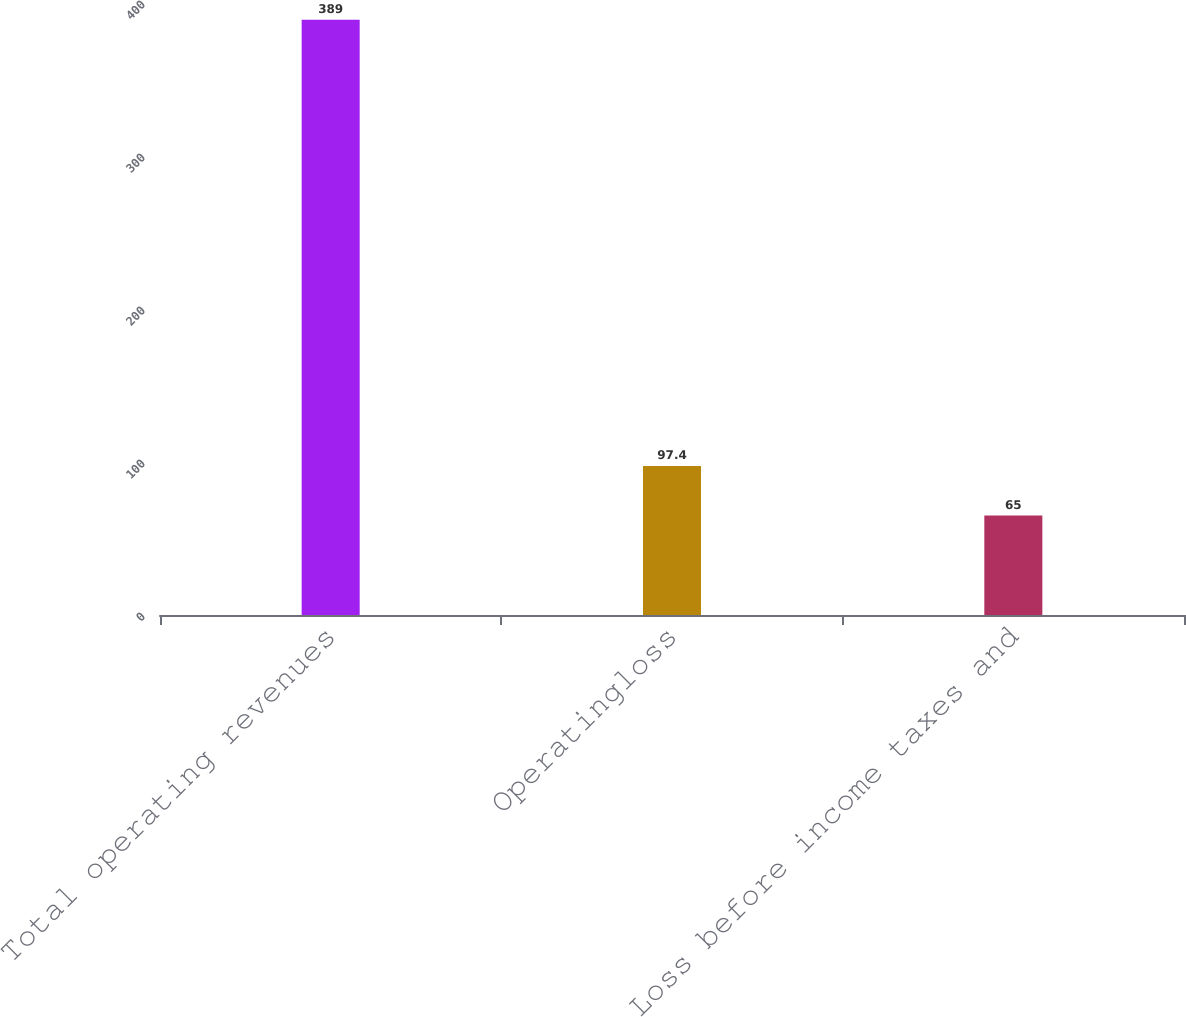<chart> <loc_0><loc_0><loc_500><loc_500><bar_chart><fcel>Total operating revenues<fcel>Operatingloss<fcel>Loss before income taxes and<nl><fcel>389<fcel>97.4<fcel>65<nl></chart> 